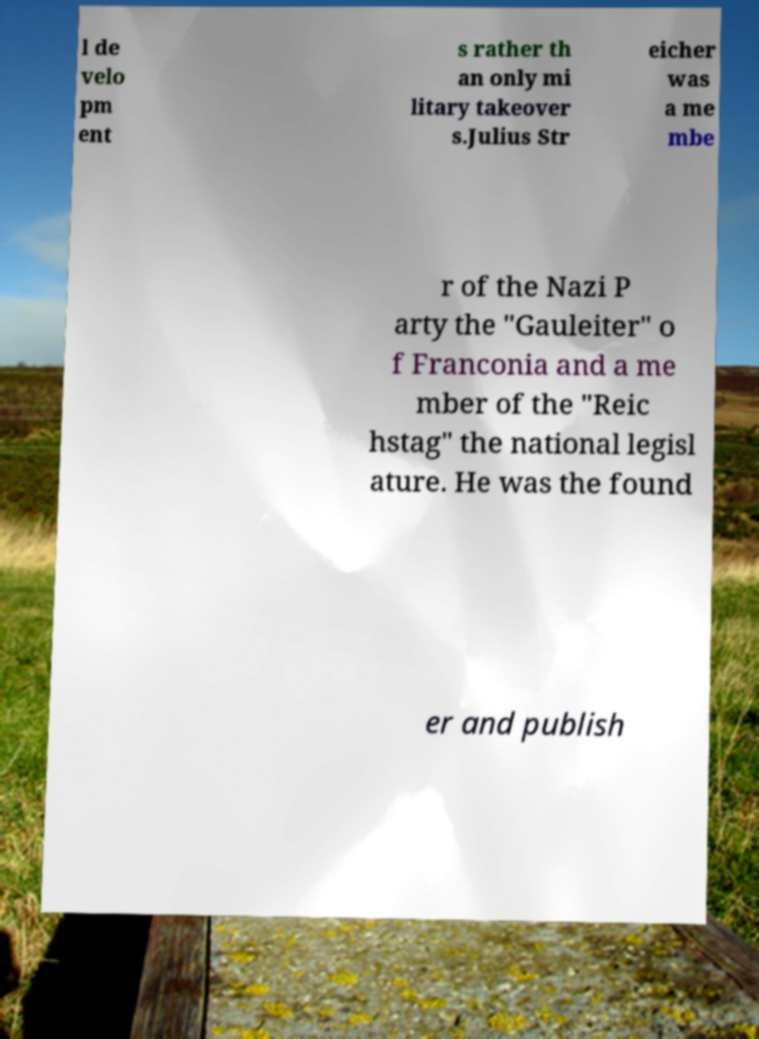Please identify and transcribe the text found in this image. l de velo pm ent s rather th an only mi litary takeover s.Julius Str eicher was a me mbe r of the Nazi P arty the "Gauleiter" o f Franconia and a me mber of the "Reic hstag" the national legisl ature. He was the found er and publish 